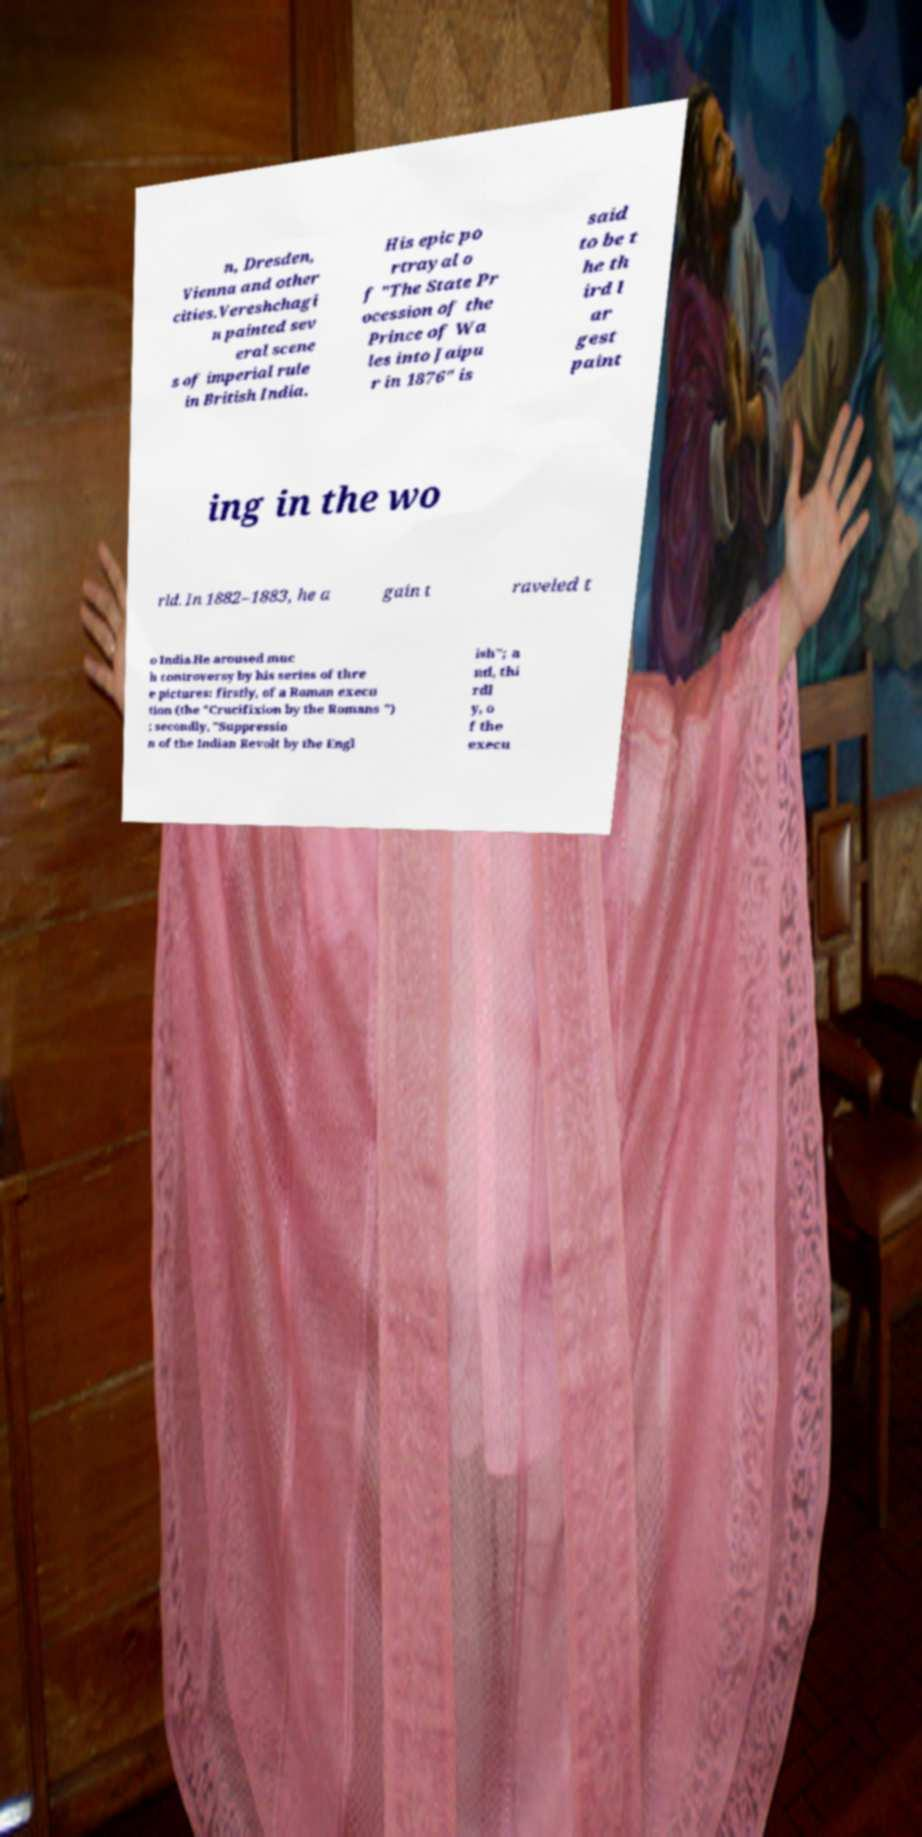Can you read and provide the text displayed in the image?This photo seems to have some interesting text. Can you extract and type it out for me? n, Dresden, Vienna and other cities.Vereshchagi n painted sev eral scene s of imperial rule in British India. His epic po rtrayal o f "The State Pr ocession of the Prince of Wa les into Jaipu r in 1876" is said to be t he th ird l ar gest paint ing in the wo rld. In 1882–1883, he a gain t raveled t o India.He aroused muc h controversy by his series of thre e pictures: firstly, of a Roman execu tion (the "Crucifixion by the Romans ") ; secondly, "Suppressio n of the Indian Revolt by the Engl ish"; a nd, thi rdl y, o f the execu 